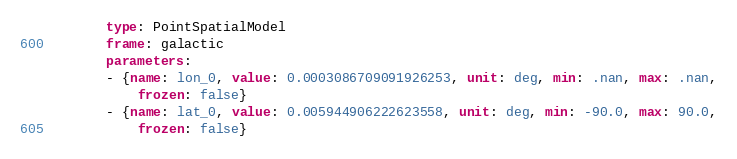Convert code to text. <code><loc_0><loc_0><loc_500><loc_500><_YAML_>        type: PointSpatialModel
        frame: galactic
        parameters:
        - {name: lon_0, value: 0.0003086709091926253, unit: deg, min: .nan, max: .nan,
            frozen: false}
        - {name: lat_0, value: 0.005944906222623558, unit: deg, min: -90.0, max: 90.0,
            frozen: false}
</code> 